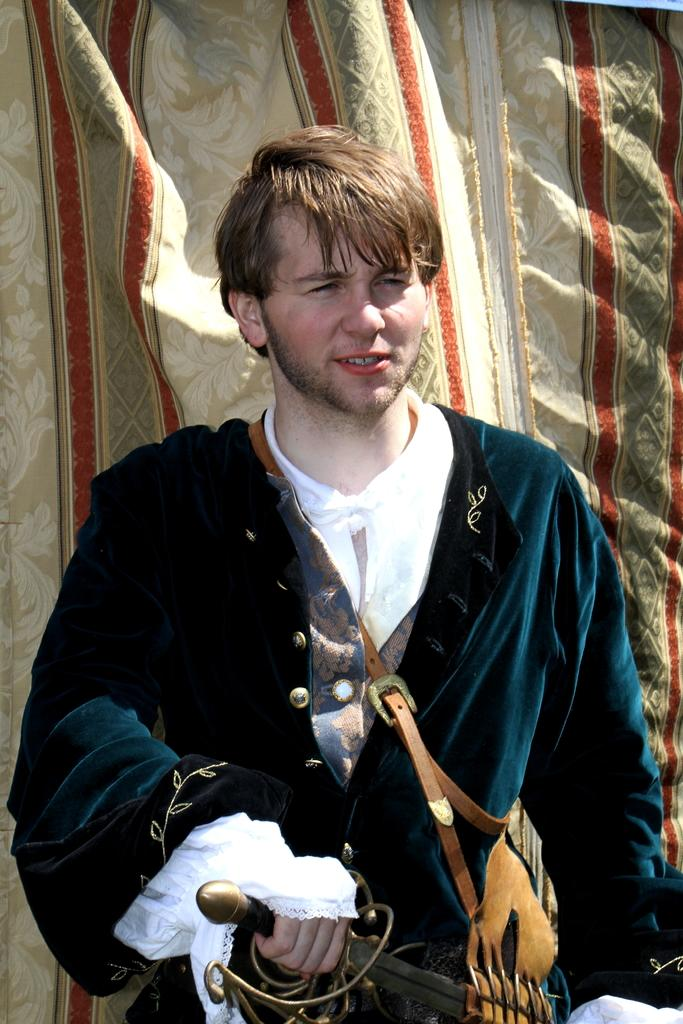What is the person in the image doing? The person is standing in the image. What is the person wearing? The person is wearing a blue coat. What object is the person holding? The person is holding a sword. Where is the sword located in the image? The sword is in the middle of the image. What can be seen in the background of the image? There is a curtain in the background of the image. How many cakes are on the table next to the person in the image? There is no table or cakes present in the image. What type of organization does the person belong to in the image? There is no information about the person's organization in the image. 